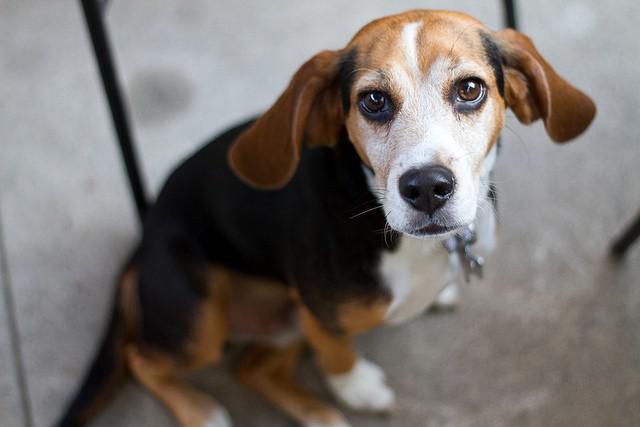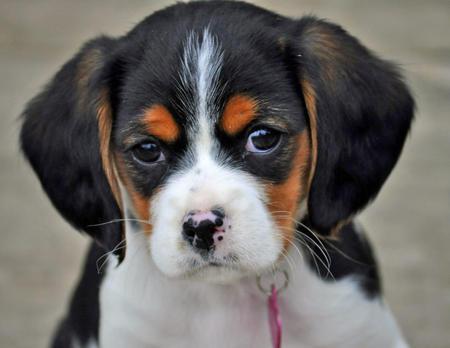The first image is the image on the left, the second image is the image on the right. For the images shown, is this caption "The dog in the image on the right has a predominately black head." true? Answer yes or no. Yes. The first image is the image on the left, the second image is the image on the right. For the images displayed, is the sentence "One dog has a black 'mask' around its eyes, and one of the dogs has a longer muzzle than the other dog." factually correct? Answer yes or no. Yes. 